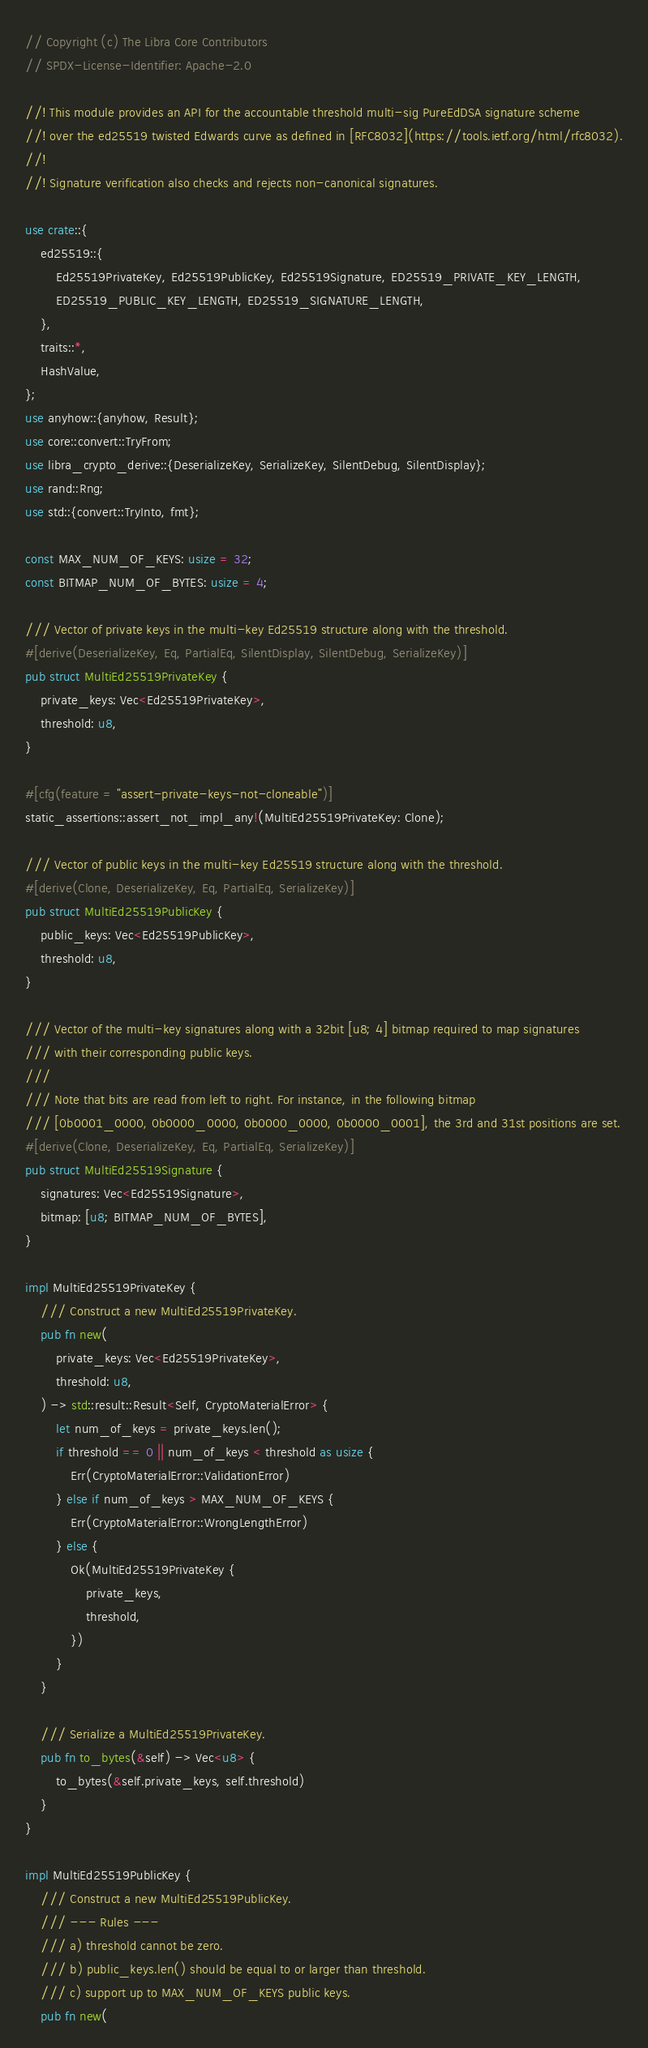Convert code to text. <code><loc_0><loc_0><loc_500><loc_500><_Rust_>// Copyright (c) The Libra Core Contributors
// SPDX-License-Identifier: Apache-2.0

//! This module provides an API for the accountable threshold multi-sig PureEdDSA signature scheme
//! over the ed25519 twisted Edwards curve as defined in [RFC8032](https://tools.ietf.org/html/rfc8032).
//!
//! Signature verification also checks and rejects non-canonical signatures.

use crate::{
    ed25519::{
        Ed25519PrivateKey, Ed25519PublicKey, Ed25519Signature, ED25519_PRIVATE_KEY_LENGTH,
        ED25519_PUBLIC_KEY_LENGTH, ED25519_SIGNATURE_LENGTH,
    },
    traits::*,
    HashValue,
};
use anyhow::{anyhow, Result};
use core::convert::TryFrom;
use libra_crypto_derive::{DeserializeKey, SerializeKey, SilentDebug, SilentDisplay};
use rand::Rng;
use std::{convert::TryInto, fmt};

const MAX_NUM_OF_KEYS: usize = 32;
const BITMAP_NUM_OF_BYTES: usize = 4;

/// Vector of private keys in the multi-key Ed25519 structure along with the threshold.
#[derive(DeserializeKey, Eq, PartialEq, SilentDisplay, SilentDebug, SerializeKey)]
pub struct MultiEd25519PrivateKey {
    private_keys: Vec<Ed25519PrivateKey>,
    threshold: u8,
}

#[cfg(feature = "assert-private-keys-not-cloneable")]
static_assertions::assert_not_impl_any!(MultiEd25519PrivateKey: Clone);

/// Vector of public keys in the multi-key Ed25519 structure along with the threshold.
#[derive(Clone, DeserializeKey, Eq, PartialEq, SerializeKey)]
pub struct MultiEd25519PublicKey {
    public_keys: Vec<Ed25519PublicKey>,
    threshold: u8,
}

/// Vector of the multi-key signatures along with a 32bit [u8; 4] bitmap required to map signatures
/// with their corresponding public keys.
///
/// Note that bits are read from left to right. For instance, in the following bitmap
/// [0b0001_0000, 0b0000_0000, 0b0000_0000, 0b0000_0001], the 3rd and 31st positions are set.
#[derive(Clone, DeserializeKey, Eq, PartialEq, SerializeKey)]
pub struct MultiEd25519Signature {
    signatures: Vec<Ed25519Signature>,
    bitmap: [u8; BITMAP_NUM_OF_BYTES],
}

impl MultiEd25519PrivateKey {
    /// Construct a new MultiEd25519PrivateKey.
    pub fn new(
        private_keys: Vec<Ed25519PrivateKey>,
        threshold: u8,
    ) -> std::result::Result<Self, CryptoMaterialError> {
        let num_of_keys = private_keys.len();
        if threshold == 0 || num_of_keys < threshold as usize {
            Err(CryptoMaterialError::ValidationError)
        } else if num_of_keys > MAX_NUM_OF_KEYS {
            Err(CryptoMaterialError::WrongLengthError)
        } else {
            Ok(MultiEd25519PrivateKey {
                private_keys,
                threshold,
            })
        }
    }

    /// Serialize a MultiEd25519PrivateKey.
    pub fn to_bytes(&self) -> Vec<u8> {
        to_bytes(&self.private_keys, self.threshold)
    }
}

impl MultiEd25519PublicKey {
    /// Construct a new MultiEd25519PublicKey.
    /// --- Rules ---
    /// a) threshold cannot be zero.
    /// b) public_keys.len() should be equal to or larger than threshold.
    /// c) support up to MAX_NUM_OF_KEYS public keys.
    pub fn new(</code> 